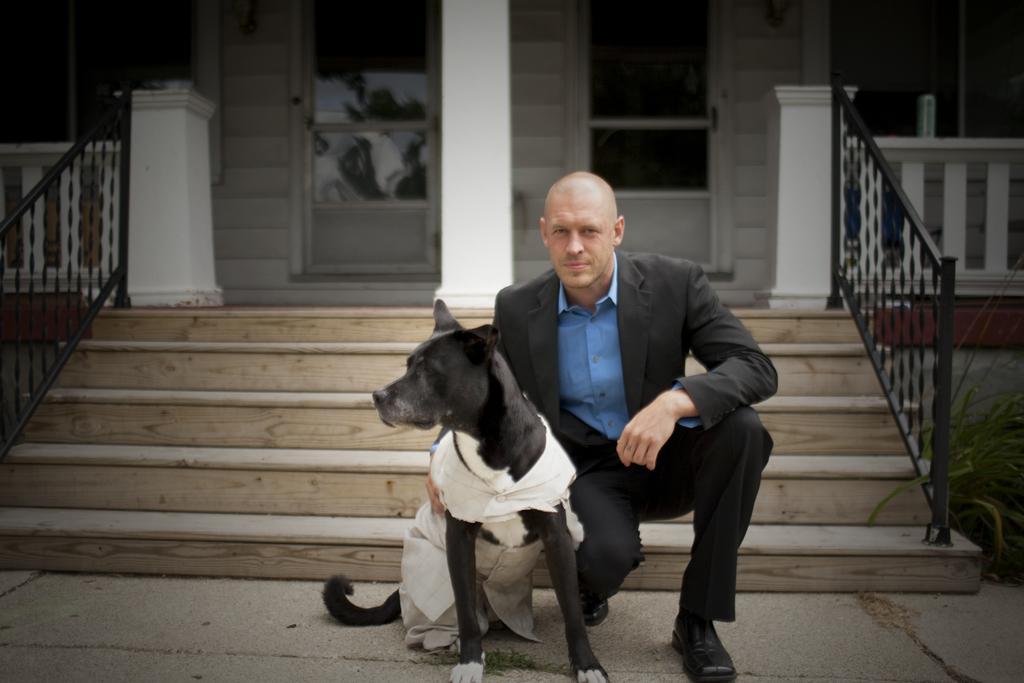In one or two sentences, can you explain what this image depicts? There is a man sitting in squat position. Beside the man I can see a dog. These are the stairs with stair case holder. At background I can see a door and pillar. At the right corner of the image I can see a small plant. 